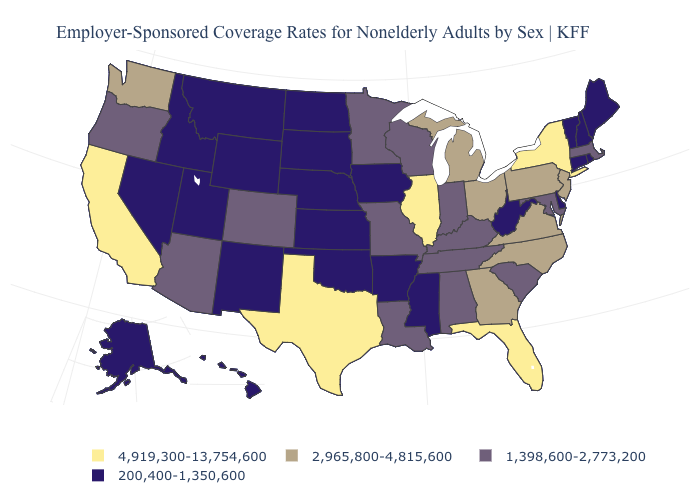What is the value of Rhode Island?
Answer briefly. 200,400-1,350,600. How many symbols are there in the legend?
Concise answer only. 4. Which states hav the highest value in the South?
Quick response, please. Florida, Texas. Name the states that have a value in the range 200,400-1,350,600?
Concise answer only. Alaska, Arkansas, Connecticut, Delaware, Hawaii, Idaho, Iowa, Kansas, Maine, Mississippi, Montana, Nebraska, Nevada, New Hampshire, New Mexico, North Dakota, Oklahoma, Rhode Island, South Dakota, Utah, Vermont, West Virginia, Wyoming. What is the value of Idaho?
Give a very brief answer. 200,400-1,350,600. Does Kentucky have the lowest value in the South?
Write a very short answer. No. What is the lowest value in states that border Texas?
Write a very short answer. 200,400-1,350,600. What is the lowest value in the USA?
Give a very brief answer. 200,400-1,350,600. Name the states that have a value in the range 4,919,300-13,754,600?
Answer briefly. California, Florida, Illinois, New York, Texas. Name the states that have a value in the range 1,398,600-2,773,200?
Write a very short answer. Alabama, Arizona, Colorado, Indiana, Kentucky, Louisiana, Maryland, Massachusetts, Minnesota, Missouri, Oregon, South Carolina, Tennessee, Wisconsin. What is the lowest value in the MidWest?
Be succinct. 200,400-1,350,600. Which states have the highest value in the USA?
Write a very short answer. California, Florida, Illinois, New York, Texas. What is the value of New Hampshire?
Be succinct. 200,400-1,350,600. Does the first symbol in the legend represent the smallest category?
Concise answer only. No. Does Oregon have the lowest value in the West?
Be succinct. No. 